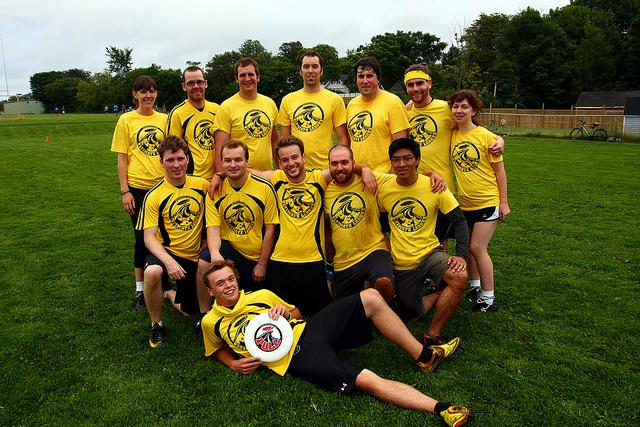What game do these men play?
Keep it brief. Frisbee. What is the player holding?
Short answer required. Frisbee. How many players are there?
Quick response, please. 13. 